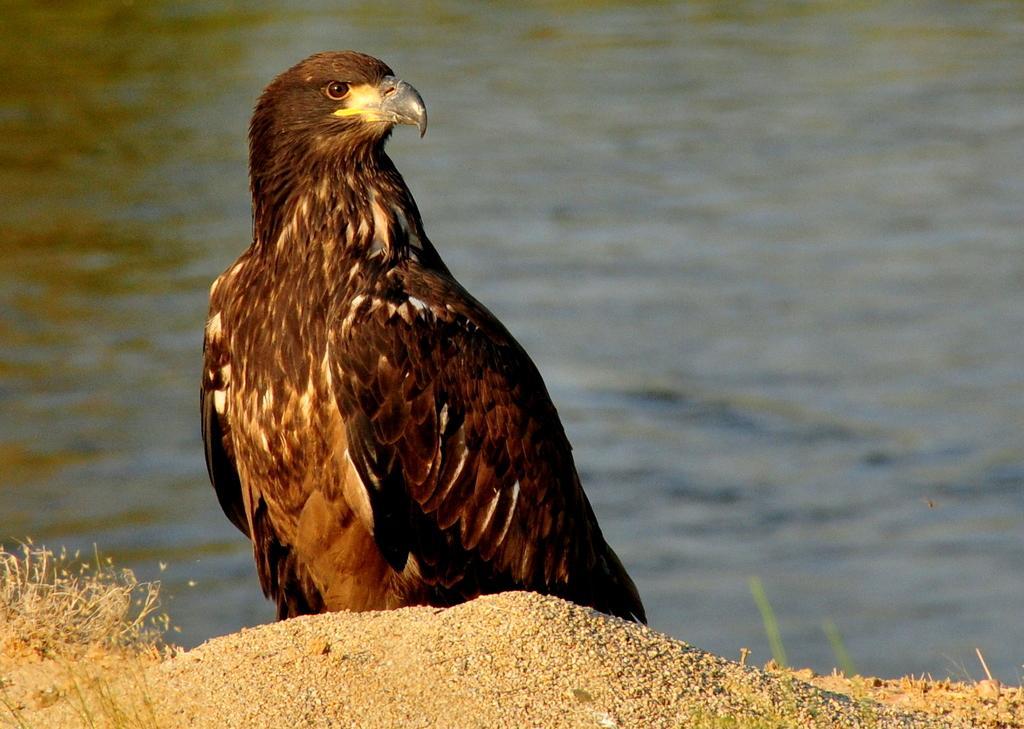Could you give a brief overview of what you see in this image? In the foreground of the picture we can see an eagle, sand and grass. In the background there is a water body 